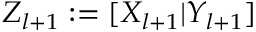Convert formula to latex. <formula><loc_0><loc_0><loc_500><loc_500>Z _ { l + 1 } \colon = [ X _ { l + 1 } | Y _ { l + 1 } ]</formula> 